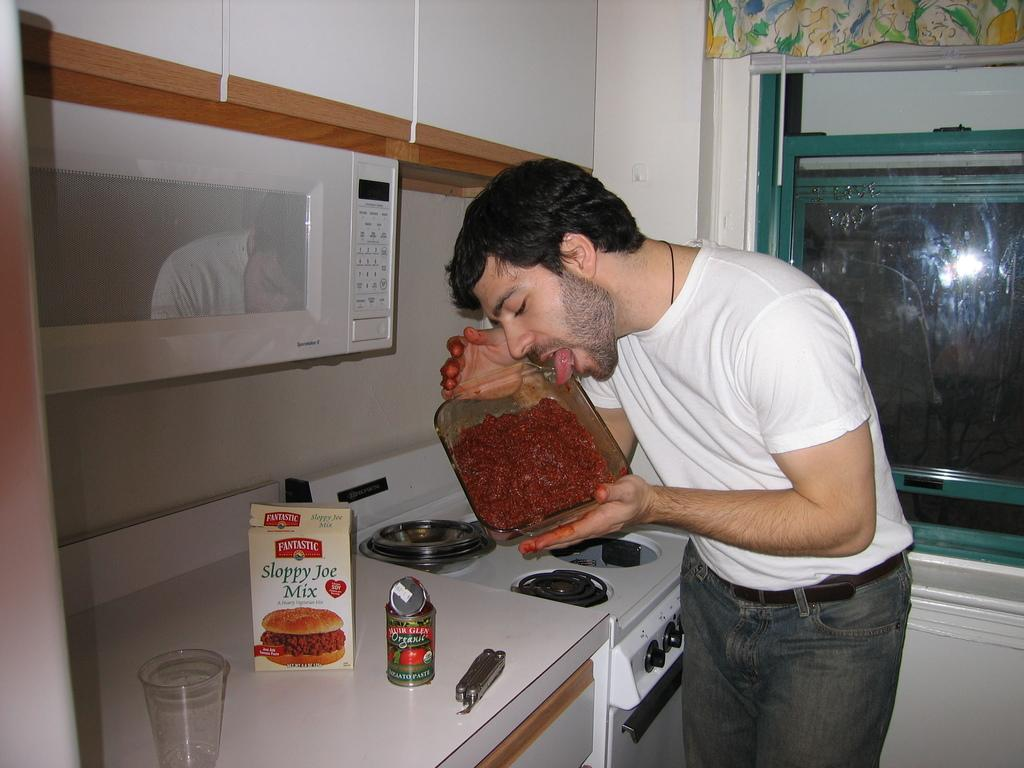Who is present in the image? There is a man in the image. What is the man holding in the image? The man is holding a bowl of jam. What is the man doing with the jam? The man is licking the jam. What can be seen on the kitchen platform in the image? There is an oven on the kitchen platform. What else is present on the kitchen platform? There are rows on the kitchen platform. What is the man thinking about in the image? The image does not provide any information about the man's thoughts. --- Facts: 1. There is a person in the image. 2. The person is wearing a hat. 3. The person is holding a book. 4. The person is sitting on a chair. 5. There is a table in the image. 6. There is a lamp on the table. Absurd Topics: elephant, piano, dancer Conversation: Who is present in the image? There is a person in the image. What is the person wearing in the image? The person is wearing a hat. What is the person holding in the image? The person is holding a book. What is the person doing in the image? The person is sitting on a chair. What can be seen on the table in the image? There is a lamp on the table. Reasoning: Let's think step by step in order to produce the conversation. We start by identifying the main subject in the image, which is the person. Then, we describe specific details about the person, such as the hat and the book they are holding. Next, we observe the person's actions, noting that they are sitting on a chair. Finally, we describe the objects present on the table, which is a lamp. Each question is designed to elicit a specific detail about the image that is known from the provided facts. Absurd Question/Answer: Can you hear the elephant playing the piano in the image? There is no mention of an elephant, a piano, or a dancer in the image. 